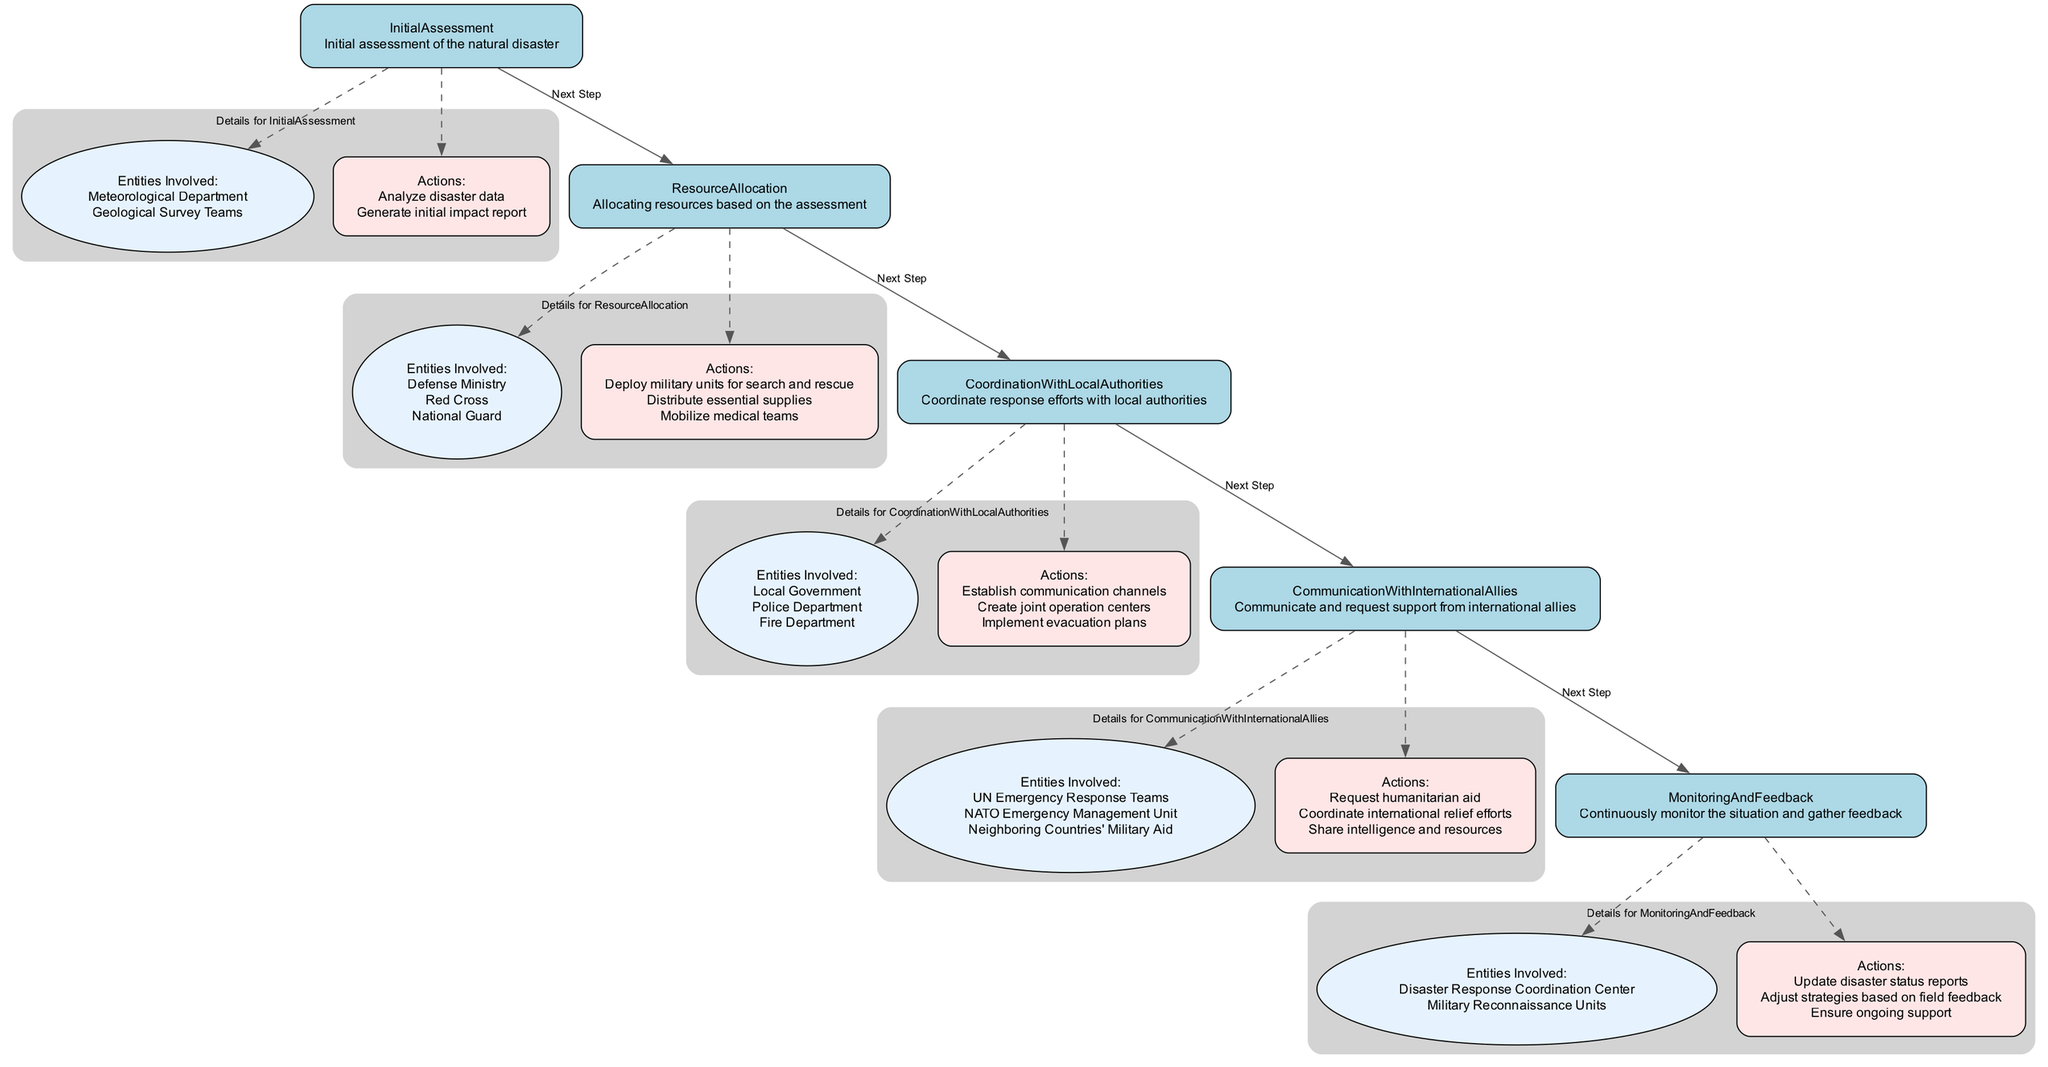What is the first step in the crisis management process? The first step is "Initial Assessment," which is indicated as the starting node in the flowchart.
Answer: Initial Assessment How many entities are involved in the Resource Allocation step? The Resource Allocation step lists three entities: Defense Ministry, Red Cross, and National Guard.
Answer: Three What action is associated with the Coordination With Local Authorities step? A notable action within this step is to "Establish communication channels," which is one of the key actions listed.
Answer: Establish communication channels Which entity is responsible for continuous monitoring and feedback? The "Disaster Response Coordination Center" is the main entity listed under the Monitoring and Feedback step.
Answer: Disaster Response Coordination Center What is the last step in the crisis management process? The last step is "Monitoring And Feedback," as indicated by the flowchart structure that progresses through each step to the end.
Answer: Monitoring And Feedback What action involves international allies? The action "Request humanitarian aid" is directly related to the interaction with international allies during the crisis management process.
Answer: Request humanitarian aid Which phase includes the deployment of military units? The deployment of military units is part of the "Resource Allocation" phase, which details the actions taken following the assessment.
Answer: Resource Allocation How many total main steps are there in the crisis management flowchart? The diagram lists five main steps in the crisis management flowchart: Initial Assessment, Resource Allocation, Coordination With Local Authorities, Communication With International Allies, and Monitoring And Feedback.
Answer: Five Which entity is involved in the communication with international allies? The "UN Emergency Response Teams" is one of the entities involved in this phase of the crisis management process, as stated in the corresponding section.
Answer: UN Emergency Response Teams 